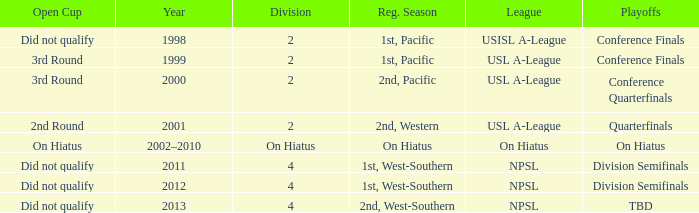Which playoffs took place during 2011? Division Semifinals. Could you parse the entire table? {'header': ['Open Cup', 'Year', 'Division', 'Reg. Season', 'League', 'Playoffs'], 'rows': [['Did not qualify', '1998', '2', '1st, Pacific', 'USISL A-League', 'Conference Finals'], ['3rd Round', '1999', '2', '1st, Pacific', 'USL A-League', 'Conference Finals'], ['3rd Round', '2000', '2', '2nd, Pacific', 'USL A-League', 'Conference Quarterfinals'], ['2nd Round', '2001', '2', '2nd, Western', 'USL A-League', 'Quarterfinals'], ['On Hiatus', '2002–2010', 'On Hiatus', 'On Hiatus', 'On Hiatus', 'On Hiatus'], ['Did not qualify', '2011', '4', '1st, West-Southern', 'NPSL', 'Division Semifinals'], ['Did not qualify', '2012', '4', '1st, West-Southern', 'NPSL', 'Division Semifinals'], ['Did not qualify', '2013', '4', '2nd, West-Southern', 'NPSL', 'TBD']]} 